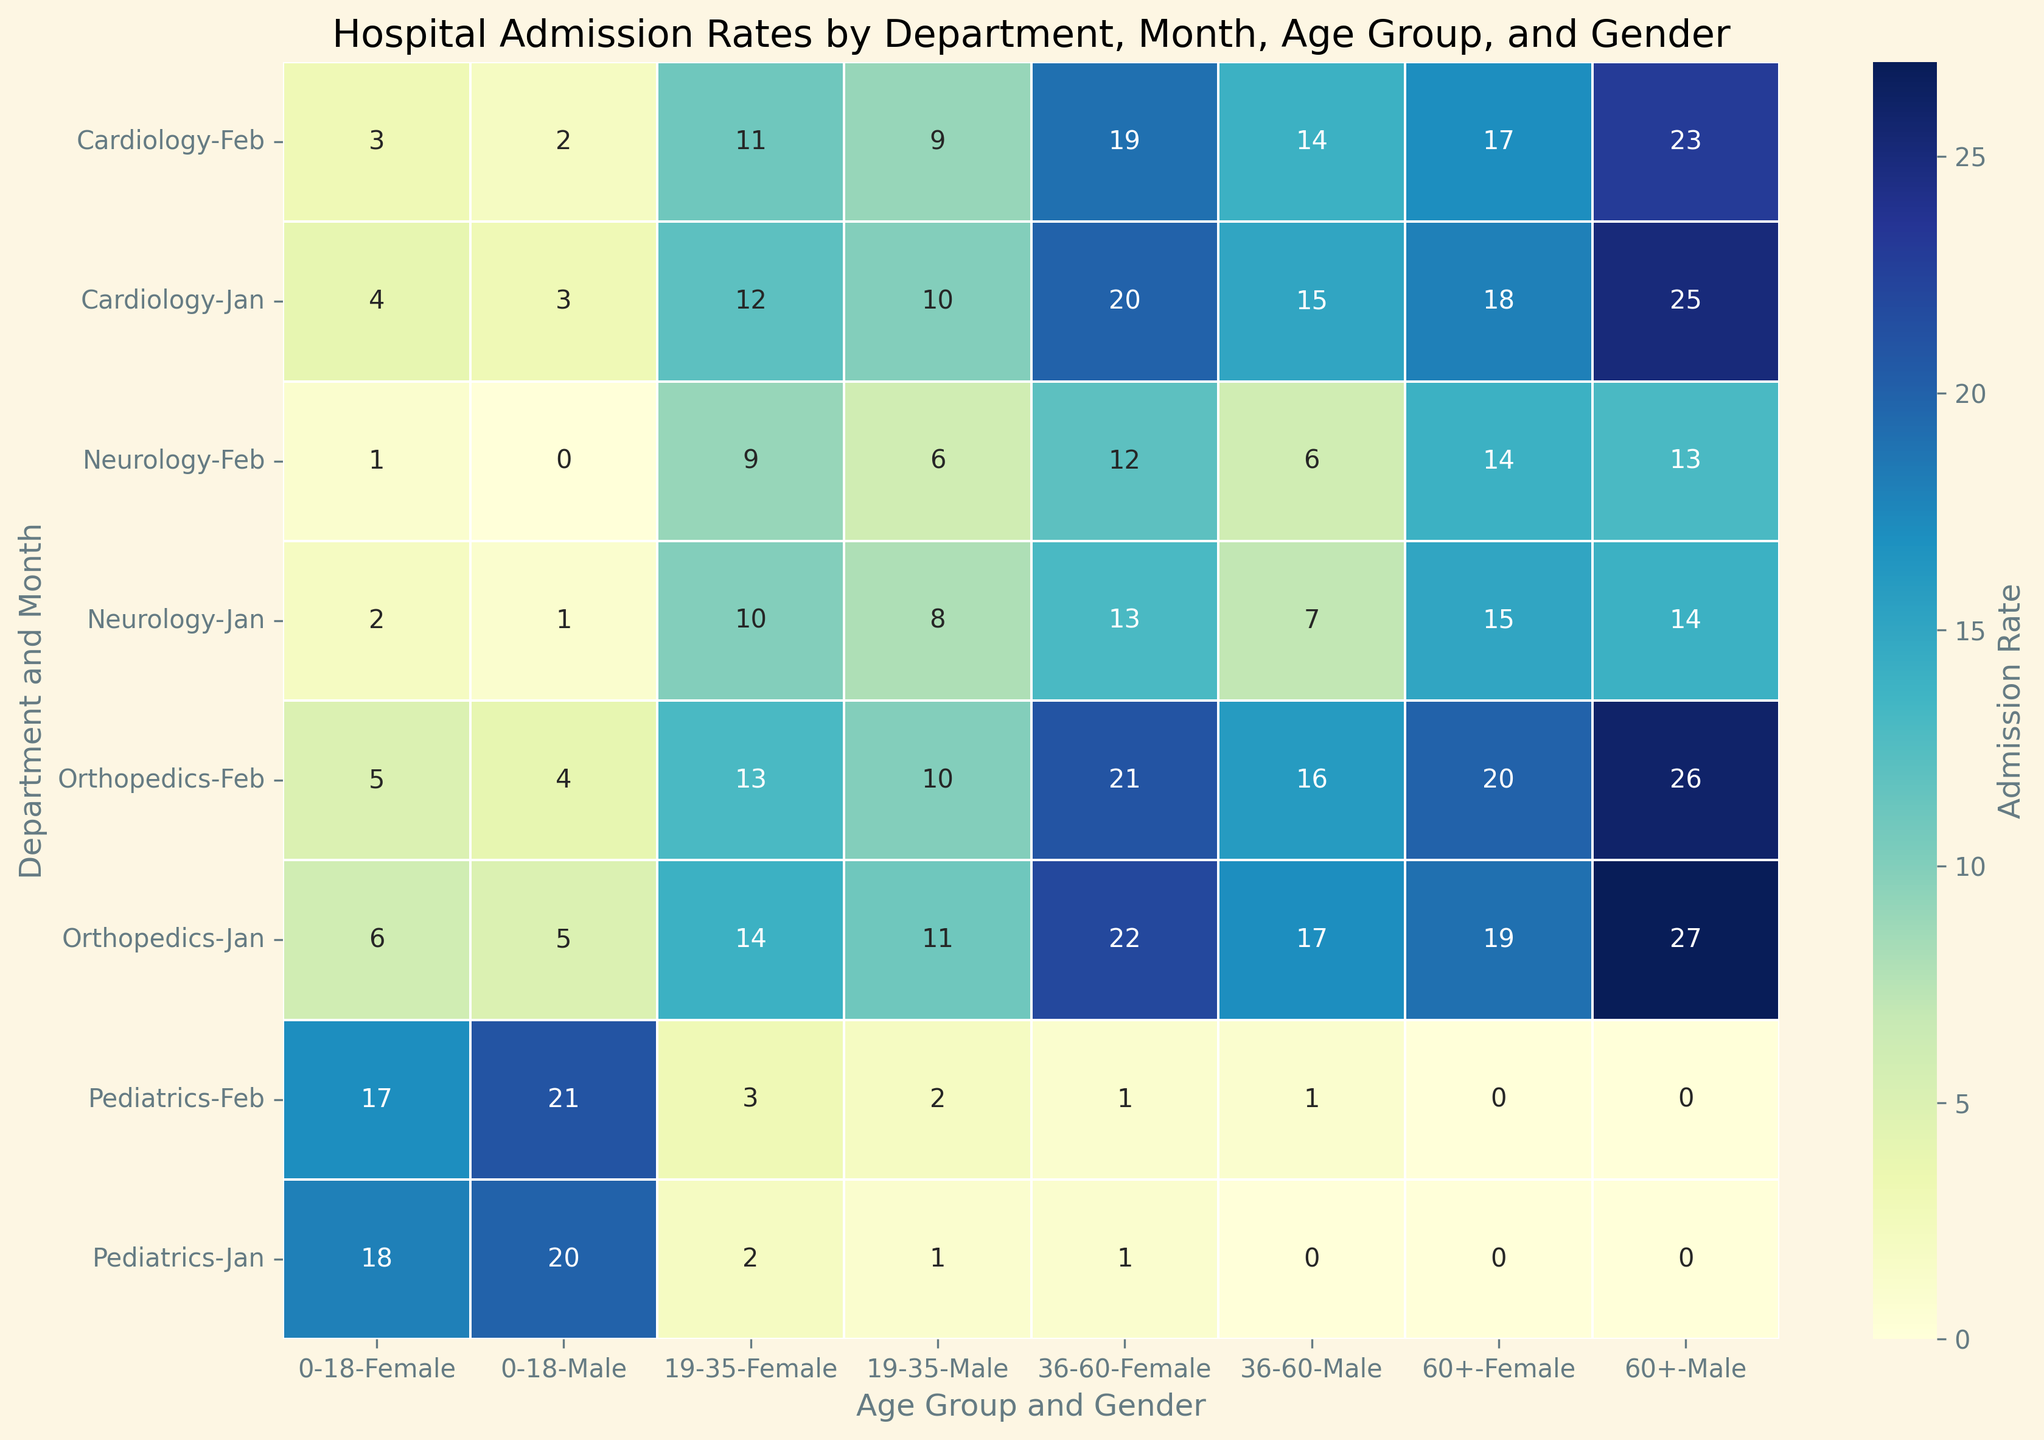What is the admission rate for Cardiology in January for the age group 60+ and gender Male? First, locate the row corresponding to Cardiology in January. Then, find the cell where the Age Group is 60+ and Gender is Male. The admission rate in that cell is the answer.
Answer: 25 Between Cardiology and Neurology in February, which department has a higher admission rate for the age group 19-35 and gender Female? Look at the cells corresponding to Cardiology in February and Neurology in February for the Age Group 19-35 and Gender Female. Compare the two values. Cardiology has 11 and Neurology has 9.
Answer: Cardiology What is the difference in admission rates between Male and Female for the age group 36-60 in January in Orthopedics? Locate the row for Orthopedics in January and find the cells for the Age Group 36-60 for both Male and Female. Subtract the Male value from the Female value (22 - 17).
Answer: 5 Which department has the highest overall admission rate for January, considering all age groups and genders? Sum the admission rates for each department in January across all age groups and genders. Compare the totals for each department. Pediatrics totals (20+18+1+2+0+1+0+0) = 42, which is the highest.
Answer: Pediatrics In February, what is the total admission rate for females across all departments and age groups? Sum the female admission rates for February across all departments and age groups. The calculation is: Cardiology (3+11+19+17) + Neurology (1+9+12+14) + Pediatrics (17+3+1+0) + Orthopedics (5+13+21+20) = 162.
Answer: 162 Compare the admission rates for Neurology in January for the age group 0-18, how does the rate differ between Male and Female patients? Find the admission rates for Neurology in January for the age group 0-18 for both Male and Female. The values are 1 for Male and 2 for Female. The difference is (2 - 1).
Answer: 1 What is the average admission rate across all age groups and genders in Pediatrics for February? Sum the admission rates for Pediatrics in February for all age groups and genders, then divide by the number of data points (8). Calculation: (21+17+2+3+1+1+0+0) / 8 = 5.625.
Answer: 5.625 